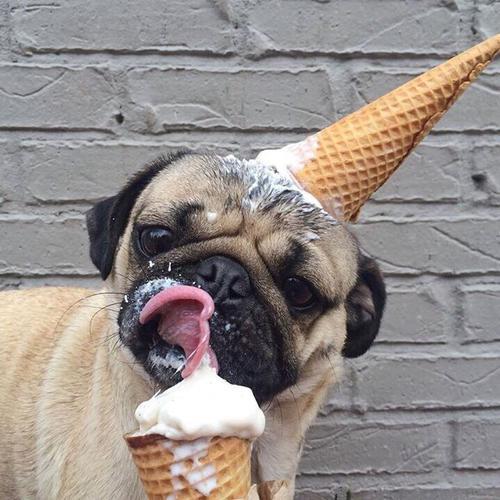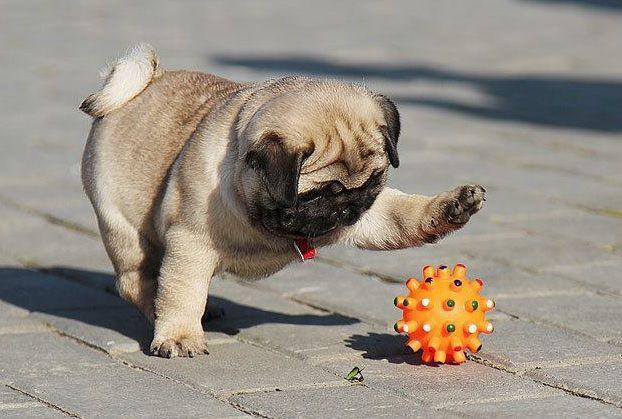The first image is the image on the left, the second image is the image on the right. For the images shown, is this caption "One image shows a pug sitting, with its hind legs extended, on cement next to something made of metal." true? Answer yes or no. No. The first image is the image on the left, the second image is the image on the right. Analyze the images presented: Is the assertion "The left image contains no more than one dog." valid? Answer yes or no. Yes. 